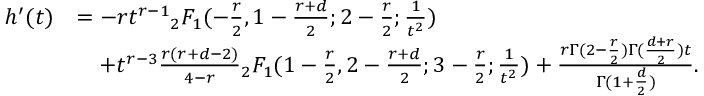Convert formula to latex. <formula><loc_0><loc_0><loc_500><loc_500>\begin{array} { r l } { h ^ { \prime } ( t ) } & { = - r t ^ { r - 1 } { _ { 2 } F _ { 1 } } ( - \frac { r } { 2 } , 1 - \frac { r + d } { 2 } ; 2 - \frac { r } { 2 } ; \frac { 1 } { t ^ { 2 } } ) } \\ & { \quad + t ^ { r - 3 } \frac { r ( r + d - 2 ) } { 4 - r } { _ { 2 } F _ { 1 } } ( 1 - \frac { r } { 2 } , 2 - \frac { r + d } { 2 } ; 3 - \frac { r } { 2 } ; \frac { 1 } { t ^ { 2 } } ) + \frac { r \Gamma ( 2 - \frac { r } 2 ) \Gamma ( \frac { d + r } { 2 } ) t } { \Gamma ( 1 + \frac { d } { 2 } ) } . } \end{array}</formula> 